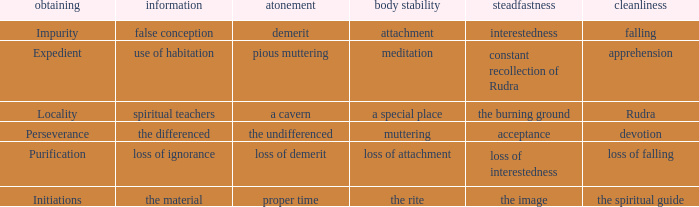What is the total number of constancy where purity is falling 1.0. Would you be able to parse every entry in this table? {'header': ['obtaining', 'information', 'atonement', 'body stability', 'steadfastness', 'cleanliness'], 'rows': [['Impurity', 'false conception', 'demerit', 'attachment', 'interestedness', 'falling'], ['Expedient', 'use of habitation', 'pious muttering', 'meditation', 'constant recollection of Rudra', 'apprehension'], ['Locality', 'spiritual teachers', 'a cavern', 'a special place', 'the burning ground', 'Rudra'], ['Perseverance', 'the differenced', 'the undifferenced', 'muttering', 'acceptance', 'devotion'], ['Purification', 'loss of ignorance', 'loss of demerit', 'loss of attachment', 'loss of interestedness', 'loss of falling'], ['Initiations', 'the material', 'proper time', 'the rite', 'the image', 'the spiritual guide']]} 